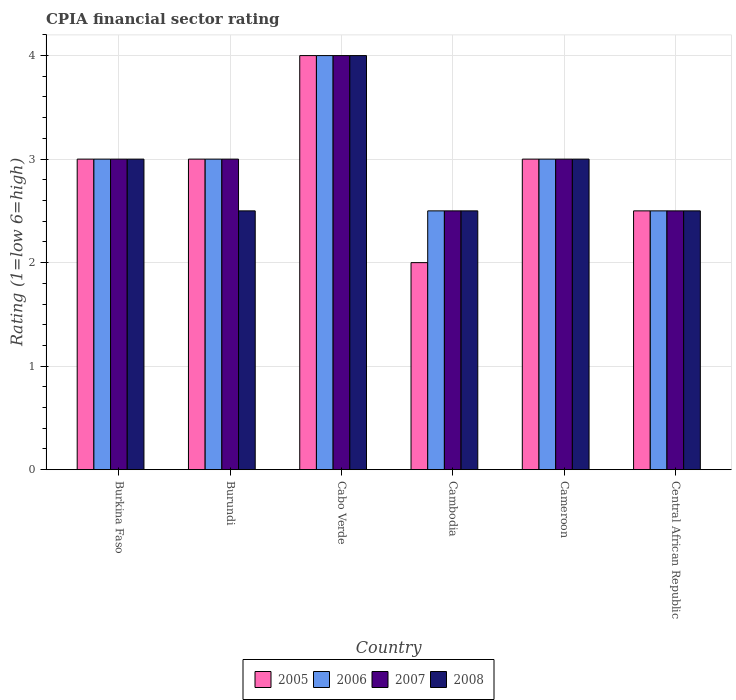How many groups of bars are there?
Your response must be concise. 6. Are the number of bars per tick equal to the number of legend labels?
Provide a short and direct response. Yes. Are the number of bars on each tick of the X-axis equal?
Offer a very short reply. Yes. How many bars are there on the 3rd tick from the left?
Provide a short and direct response. 4. How many bars are there on the 3rd tick from the right?
Keep it short and to the point. 4. What is the label of the 1st group of bars from the left?
Offer a very short reply. Burkina Faso. Across all countries, what is the maximum CPIA rating in 2006?
Provide a short and direct response. 4. Across all countries, what is the minimum CPIA rating in 2005?
Provide a short and direct response. 2. In which country was the CPIA rating in 2008 maximum?
Your response must be concise. Cabo Verde. In which country was the CPIA rating in 2007 minimum?
Offer a terse response. Cambodia. What is the average CPIA rating in 2005 per country?
Provide a succinct answer. 2.92. What is the difference between the CPIA rating of/in 2005 and CPIA rating of/in 2006 in Cameroon?
Provide a succinct answer. 0. Is the CPIA rating in 2006 in Burundi less than that in Cameroon?
Your answer should be compact. No. What is the difference between the highest and the second highest CPIA rating in 2006?
Offer a very short reply. -1. What is the difference between the highest and the lowest CPIA rating in 2006?
Offer a very short reply. 1.5. In how many countries, is the CPIA rating in 2007 greater than the average CPIA rating in 2007 taken over all countries?
Ensure brevity in your answer.  1. Is the sum of the CPIA rating in 2006 in Burkina Faso and Burundi greater than the maximum CPIA rating in 2008 across all countries?
Your response must be concise. Yes. Is it the case that in every country, the sum of the CPIA rating in 2008 and CPIA rating in 2006 is greater than the sum of CPIA rating in 2005 and CPIA rating in 2007?
Your answer should be compact. No. What does the 2nd bar from the right in Cambodia represents?
Your answer should be compact. 2007. How many bars are there?
Make the answer very short. 24. What is the difference between two consecutive major ticks on the Y-axis?
Offer a terse response. 1. Does the graph contain any zero values?
Keep it short and to the point. No. Where does the legend appear in the graph?
Your answer should be very brief. Bottom center. How are the legend labels stacked?
Make the answer very short. Horizontal. What is the title of the graph?
Your response must be concise. CPIA financial sector rating. What is the label or title of the X-axis?
Your answer should be compact. Country. What is the Rating (1=low 6=high) in 2006 in Burkina Faso?
Offer a terse response. 3. What is the Rating (1=low 6=high) in 2007 in Burkina Faso?
Your answer should be compact. 3. What is the Rating (1=low 6=high) of 2008 in Burkina Faso?
Provide a short and direct response. 3. What is the Rating (1=low 6=high) in 2005 in Burundi?
Your answer should be very brief. 3. What is the Rating (1=low 6=high) of 2006 in Burundi?
Provide a succinct answer. 3. What is the Rating (1=low 6=high) in 2008 in Burundi?
Your answer should be compact. 2.5. What is the Rating (1=low 6=high) in 2007 in Cabo Verde?
Provide a succinct answer. 4. What is the Rating (1=low 6=high) in 2005 in Cambodia?
Provide a short and direct response. 2. What is the Rating (1=low 6=high) in 2008 in Cambodia?
Provide a short and direct response. 2.5. What is the Rating (1=low 6=high) of 2007 in Cameroon?
Keep it short and to the point. 3. What is the Rating (1=low 6=high) in 2008 in Cameroon?
Give a very brief answer. 3. What is the Rating (1=low 6=high) of 2006 in Central African Republic?
Make the answer very short. 2.5. What is the Rating (1=low 6=high) in 2007 in Central African Republic?
Provide a short and direct response. 2.5. Across all countries, what is the maximum Rating (1=low 6=high) in 2005?
Provide a succinct answer. 4. Across all countries, what is the maximum Rating (1=low 6=high) in 2006?
Give a very brief answer. 4. Across all countries, what is the minimum Rating (1=low 6=high) in 2006?
Provide a short and direct response. 2.5. Across all countries, what is the minimum Rating (1=low 6=high) in 2007?
Give a very brief answer. 2.5. Across all countries, what is the minimum Rating (1=low 6=high) of 2008?
Ensure brevity in your answer.  2.5. What is the difference between the Rating (1=low 6=high) of 2005 in Burkina Faso and that in Burundi?
Your answer should be compact. 0. What is the difference between the Rating (1=low 6=high) in 2008 in Burkina Faso and that in Burundi?
Provide a short and direct response. 0.5. What is the difference between the Rating (1=low 6=high) in 2005 in Burkina Faso and that in Cabo Verde?
Give a very brief answer. -1. What is the difference between the Rating (1=low 6=high) in 2006 in Burkina Faso and that in Cabo Verde?
Provide a succinct answer. -1. What is the difference between the Rating (1=low 6=high) in 2005 in Burkina Faso and that in Cambodia?
Provide a short and direct response. 1. What is the difference between the Rating (1=low 6=high) of 2006 in Burkina Faso and that in Cambodia?
Offer a very short reply. 0.5. What is the difference between the Rating (1=low 6=high) in 2008 in Burkina Faso and that in Cambodia?
Offer a terse response. 0.5. What is the difference between the Rating (1=low 6=high) in 2005 in Burkina Faso and that in Cameroon?
Provide a succinct answer. 0. What is the difference between the Rating (1=low 6=high) of 2008 in Burkina Faso and that in Cameroon?
Provide a short and direct response. 0. What is the difference between the Rating (1=low 6=high) in 2007 in Burundi and that in Cabo Verde?
Offer a very short reply. -1. What is the difference between the Rating (1=low 6=high) in 2005 in Burundi and that in Cambodia?
Offer a very short reply. 1. What is the difference between the Rating (1=low 6=high) of 2007 in Burundi and that in Cambodia?
Ensure brevity in your answer.  0.5. What is the difference between the Rating (1=low 6=high) of 2008 in Burundi and that in Cambodia?
Provide a short and direct response. 0. What is the difference between the Rating (1=low 6=high) in 2005 in Burundi and that in Cameroon?
Provide a succinct answer. 0. What is the difference between the Rating (1=low 6=high) in 2006 in Burundi and that in Cameroon?
Your answer should be compact. 0. What is the difference between the Rating (1=low 6=high) in 2006 in Burundi and that in Central African Republic?
Ensure brevity in your answer.  0.5. What is the difference between the Rating (1=low 6=high) in 2008 in Burundi and that in Central African Republic?
Give a very brief answer. 0. What is the difference between the Rating (1=low 6=high) in 2005 in Cabo Verde and that in Cambodia?
Offer a terse response. 2. What is the difference between the Rating (1=low 6=high) in 2008 in Cabo Verde and that in Cambodia?
Your answer should be compact. 1.5. What is the difference between the Rating (1=low 6=high) in 2005 in Cabo Verde and that in Cameroon?
Keep it short and to the point. 1. What is the difference between the Rating (1=low 6=high) in 2007 in Cabo Verde and that in Cameroon?
Offer a very short reply. 1. What is the difference between the Rating (1=low 6=high) of 2008 in Cabo Verde and that in Cameroon?
Offer a terse response. 1. What is the difference between the Rating (1=low 6=high) of 2005 in Cabo Verde and that in Central African Republic?
Give a very brief answer. 1.5. What is the difference between the Rating (1=low 6=high) in 2006 in Cabo Verde and that in Central African Republic?
Your response must be concise. 1.5. What is the difference between the Rating (1=low 6=high) in 2007 in Cambodia and that in Cameroon?
Provide a succinct answer. -0.5. What is the difference between the Rating (1=low 6=high) in 2005 in Cambodia and that in Central African Republic?
Give a very brief answer. -0.5. What is the difference between the Rating (1=low 6=high) of 2005 in Cameroon and that in Central African Republic?
Give a very brief answer. 0.5. What is the difference between the Rating (1=low 6=high) in 2005 in Burkina Faso and the Rating (1=low 6=high) in 2006 in Burundi?
Offer a very short reply. 0. What is the difference between the Rating (1=low 6=high) in 2005 in Burkina Faso and the Rating (1=low 6=high) in 2007 in Burundi?
Give a very brief answer. 0. What is the difference between the Rating (1=low 6=high) in 2005 in Burkina Faso and the Rating (1=low 6=high) in 2008 in Burundi?
Provide a succinct answer. 0.5. What is the difference between the Rating (1=low 6=high) in 2006 in Burkina Faso and the Rating (1=low 6=high) in 2007 in Burundi?
Offer a very short reply. 0. What is the difference between the Rating (1=low 6=high) of 2005 in Burkina Faso and the Rating (1=low 6=high) of 2006 in Cabo Verde?
Provide a short and direct response. -1. What is the difference between the Rating (1=low 6=high) in 2005 in Burkina Faso and the Rating (1=low 6=high) in 2007 in Cabo Verde?
Make the answer very short. -1. What is the difference between the Rating (1=low 6=high) of 2005 in Burkina Faso and the Rating (1=low 6=high) of 2008 in Cabo Verde?
Your response must be concise. -1. What is the difference between the Rating (1=low 6=high) in 2006 in Burkina Faso and the Rating (1=low 6=high) in 2007 in Cabo Verde?
Offer a very short reply. -1. What is the difference between the Rating (1=low 6=high) of 2005 in Burkina Faso and the Rating (1=low 6=high) of 2007 in Cambodia?
Give a very brief answer. 0.5. What is the difference between the Rating (1=low 6=high) in 2005 in Burkina Faso and the Rating (1=low 6=high) in 2008 in Cambodia?
Provide a succinct answer. 0.5. What is the difference between the Rating (1=low 6=high) in 2006 in Burkina Faso and the Rating (1=low 6=high) in 2007 in Cambodia?
Offer a very short reply. 0.5. What is the difference between the Rating (1=low 6=high) of 2006 in Burkina Faso and the Rating (1=low 6=high) of 2008 in Cambodia?
Your answer should be compact. 0.5. What is the difference between the Rating (1=low 6=high) in 2007 in Burkina Faso and the Rating (1=low 6=high) in 2008 in Cambodia?
Provide a succinct answer. 0.5. What is the difference between the Rating (1=low 6=high) of 2005 in Burkina Faso and the Rating (1=low 6=high) of 2006 in Cameroon?
Your response must be concise. 0. What is the difference between the Rating (1=low 6=high) of 2005 in Burkina Faso and the Rating (1=low 6=high) of 2007 in Cameroon?
Your answer should be very brief. 0. What is the difference between the Rating (1=low 6=high) of 2005 in Burkina Faso and the Rating (1=low 6=high) of 2008 in Cameroon?
Your response must be concise. 0. What is the difference between the Rating (1=low 6=high) in 2005 in Burkina Faso and the Rating (1=low 6=high) in 2006 in Central African Republic?
Make the answer very short. 0.5. What is the difference between the Rating (1=low 6=high) in 2005 in Burkina Faso and the Rating (1=low 6=high) in 2007 in Central African Republic?
Your response must be concise. 0.5. What is the difference between the Rating (1=low 6=high) in 2006 in Burkina Faso and the Rating (1=low 6=high) in 2008 in Central African Republic?
Provide a succinct answer. 0.5. What is the difference between the Rating (1=low 6=high) of 2007 in Burkina Faso and the Rating (1=low 6=high) of 2008 in Central African Republic?
Provide a succinct answer. 0.5. What is the difference between the Rating (1=low 6=high) in 2005 in Burundi and the Rating (1=low 6=high) in 2007 in Cabo Verde?
Your answer should be compact. -1. What is the difference between the Rating (1=low 6=high) of 2005 in Burundi and the Rating (1=low 6=high) of 2008 in Cabo Verde?
Provide a short and direct response. -1. What is the difference between the Rating (1=low 6=high) of 2007 in Burundi and the Rating (1=low 6=high) of 2008 in Cabo Verde?
Keep it short and to the point. -1. What is the difference between the Rating (1=low 6=high) of 2006 in Burundi and the Rating (1=low 6=high) of 2008 in Cambodia?
Your answer should be very brief. 0.5. What is the difference between the Rating (1=low 6=high) of 2007 in Burundi and the Rating (1=low 6=high) of 2008 in Cambodia?
Give a very brief answer. 0.5. What is the difference between the Rating (1=low 6=high) of 2005 in Burundi and the Rating (1=low 6=high) of 2006 in Cameroon?
Make the answer very short. 0. What is the difference between the Rating (1=low 6=high) of 2005 in Burundi and the Rating (1=low 6=high) of 2007 in Cameroon?
Your answer should be compact. 0. What is the difference between the Rating (1=low 6=high) in 2005 in Burundi and the Rating (1=low 6=high) in 2008 in Cameroon?
Give a very brief answer. 0. What is the difference between the Rating (1=low 6=high) of 2006 in Burundi and the Rating (1=low 6=high) of 2007 in Cameroon?
Offer a terse response. 0. What is the difference between the Rating (1=low 6=high) of 2007 in Burundi and the Rating (1=low 6=high) of 2008 in Cameroon?
Make the answer very short. 0. What is the difference between the Rating (1=low 6=high) of 2007 in Burundi and the Rating (1=low 6=high) of 2008 in Central African Republic?
Keep it short and to the point. 0.5. What is the difference between the Rating (1=low 6=high) in 2005 in Cabo Verde and the Rating (1=low 6=high) in 2006 in Cambodia?
Give a very brief answer. 1.5. What is the difference between the Rating (1=low 6=high) in 2005 in Cabo Verde and the Rating (1=low 6=high) in 2007 in Cambodia?
Your answer should be compact. 1.5. What is the difference between the Rating (1=low 6=high) in 2006 in Cabo Verde and the Rating (1=low 6=high) in 2007 in Cambodia?
Your answer should be compact. 1.5. What is the difference between the Rating (1=low 6=high) in 2007 in Cabo Verde and the Rating (1=low 6=high) in 2008 in Cambodia?
Offer a very short reply. 1.5. What is the difference between the Rating (1=low 6=high) of 2005 in Cabo Verde and the Rating (1=low 6=high) of 2007 in Cameroon?
Give a very brief answer. 1. What is the difference between the Rating (1=low 6=high) of 2006 in Cabo Verde and the Rating (1=low 6=high) of 2008 in Cameroon?
Keep it short and to the point. 1. What is the difference between the Rating (1=low 6=high) of 2005 in Cabo Verde and the Rating (1=low 6=high) of 2007 in Central African Republic?
Offer a very short reply. 1.5. What is the difference between the Rating (1=low 6=high) of 2006 in Cambodia and the Rating (1=low 6=high) of 2008 in Cameroon?
Your answer should be compact. -0.5. What is the difference between the Rating (1=low 6=high) in 2007 in Cambodia and the Rating (1=low 6=high) in 2008 in Cameroon?
Ensure brevity in your answer.  -0.5. What is the difference between the Rating (1=low 6=high) of 2005 in Cambodia and the Rating (1=low 6=high) of 2006 in Central African Republic?
Make the answer very short. -0.5. What is the difference between the Rating (1=low 6=high) of 2006 in Cambodia and the Rating (1=low 6=high) of 2008 in Central African Republic?
Your answer should be compact. 0. What is the difference between the Rating (1=low 6=high) of 2007 in Cambodia and the Rating (1=low 6=high) of 2008 in Central African Republic?
Your answer should be very brief. 0. What is the difference between the Rating (1=low 6=high) in 2005 in Cameroon and the Rating (1=low 6=high) in 2007 in Central African Republic?
Provide a short and direct response. 0.5. What is the difference between the Rating (1=low 6=high) of 2005 in Cameroon and the Rating (1=low 6=high) of 2008 in Central African Republic?
Ensure brevity in your answer.  0.5. What is the difference between the Rating (1=low 6=high) of 2006 in Cameroon and the Rating (1=low 6=high) of 2008 in Central African Republic?
Make the answer very short. 0.5. What is the difference between the Rating (1=low 6=high) in 2007 in Cameroon and the Rating (1=low 6=high) in 2008 in Central African Republic?
Ensure brevity in your answer.  0.5. What is the average Rating (1=low 6=high) of 2005 per country?
Your answer should be very brief. 2.92. What is the average Rating (1=low 6=high) in 2006 per country?
Provide a succinct answer. 3. What is the average Rating (1=low 6=high) in 2007 per country?
Ensure brevity in your answer.  3. What is the average Rating (1=low 6=high) in 2008 per country?
Make the answer very short. 2.92. What is the difference between the Rating (1=low 6=high) of 2005 and Rating (1=low 6=high) of 2007 in Burkina Faso?
Make the answer very short. 0. What is the difference between the Rating (1=low 6=high) in 2006 and Rating (1=low 6=high) in 2007 in Burkina Faso?
Your answer should be compact. 0. What is the difference between the Rating (1=low 6=high) in 2005 and Rating (1=low 6=high) in 2007 in Burundi?
Offer a very short reply. 0. What is the difference between the Rating (1=low 6=high) in 2007 and Rating (1=low 6=high) in 2008 in Burundi?
Your answer should be compact. 0.5. What is the difference between the Rating (1=low 6=high) of 2006 and Rating (1=low 6=high) of 2008 in Cabo Verde?
Your answer should be compact. 0. What is the difference between the Rating (1=low 6=high) of 2005 and Rating (1=low 6=high) of 2006 in Cambodia?
Make the answer very short. -0.5. What is the difference between the Rating (1=low 6=high) of 2005 and Rating (1=low 6=high) of 2007 in Cambodia?
Offer a very short reply. -0.5. What is the difference between the Rating (1=low 6=high) in 2005 and Rating (1=low 6=high) in 2008 in Cambodia?
Your response must be concise. -0.5. What is the difference between the Rating (1=low 6=high) of 2005 and Rating (1=low 6=high) of 2008 in Cameroon?
Provide a short and direct response. 0. What is the difference between the Rating (1=low 6=high) of 2006 and Rating (1=low 6=high) of 2008 in Cameroon?
Make the answer very short. 0. What is the difference between the Rating (1=low 6=high) in 2005 and Rating (1=low 6=high) in 2006 in Central African Republic?
Offer a terse response. 0. What is the difference between the Rating (1=low 6=high) in 2005 and Rating (1=low 6=high) in 2008 in Central African Republic?
Ensure brevity in your answer.  0. What is the difference between the Rating (1=low 6=high) in 2006 and Rating (1=low 6=high) in 2007 in Central African Republic?
Your response must be concise. 0. What is the difference between the Rating (1=low 6=high) of 2006 and Rating (1=low 6=high) of 2008 in Central African Republic?
Your answer should be compact. 0. What is the difference between the Rating (1=low 6=high) in 2007 and Rating (1=low 6=high) in 2008 in Central African Republic?
Make the answer very short. 0. What is the ratio of the Rating (1=low 6=high) of 2005 in Burkina Faso to that in Burundi?
Provide a succinct answer. 1. What is the ratio of the Rating (1=low 6=high) in 2006 in Burkina Faso to that in Burundi?
Provide a short and direct response. 1. What is the ratio of the Rating (1=low 6=high) of 2006 in Burkina Faso to that in Cabo Verde?
Offer a terse response. 0.75. What is the ratio of the Rating (1=low 6=high) of 2007 in Burkina Faso to that in Cabo Verde?
Your answer should be very brief. 0.75. What is the ratio of the Rating (1=low 6=high) in 2008 in Burkina Faso to that in Cabo Verde?
Your response must be concise. 0.75. What is the ratio of the Rating (1=low 6=high) in 2005 in Burkina Faso to that in Cambodia?
Your answer should be compact. 1.5. What is the ratio of the Rating (1=low 6=high) of 2006 in Burkina Faso to that in Cambodia?
Your answer should be very brief. 1.2. What is the ratio of the Rating (1=low 6=high) of 2007 in Burkina Faso to that in Cambodia?
Offer a very short reply. 1.2. What is the ratio of the Rating (1=low 6=high) in 2007 in Burkina Faso to that in Central African Republic?
Make the answer very short. 1.2. What is the ratio of the Rating (1=low 6=high) of 2005 in Burundi to that in Cabo Verde?
Offer a very short reply. 0.75. What is the ratio of the Rating (1=low 6=high) in 2006 in Burundi to that in Cabo Verde?
Provide a short and direct response. 0.75. What is the ratio of the Rating (1=low 6=high) in 2008 in Burundi to that in Cabo Verde?
Keep it short and to the point. 0.62. What is the ratio of the Rating (1=low 6=high) in 2007 in Burundi to that in Cambodia?
Your answer should be compact. 1.2. What is the ratio of the Rating (1=low 6=high) of 2008 in Burundi to that in Cambodia?
Your answer should be very brief. 1. What is the ratio of the Rating (1=low 6=high) of 2008 in Burundi to that in Cameroon?
Give a very brief answer. 0.83. What is the ratio of the Rating (1=low 6=high) in 2006 in Burundi to that in Central African Republic?
Offer a terse response. 1.2. What is the ratio of the Rating (1=low 6=high) of 2007 in Burundi to that in Central African Republic?
Your answer should be very brief. 1.2. What is the ratio of the Rating (1=low 6=high) in 2005 in Cabo Verde to that in Cambodia?
Give a very brief answer. 2. What is the ratio of the Rating (1=low 6=high) of 2005 in Cabo Verde to that in Cameroon?
Keep it short and to the point. 1.33. What is the ratio of the Rating (1=low 6=high) of 2007 in Cabo Verde to that in Cameroon?
Your answer should be compact. 1.33. What is the ratio of the Rating (1=low 6=high) in 2008 in Cabo Verde to that in Central African Republic?
Keep it short and to the point. 1.6. What is the ratio of the Rating (1=low 6=high) of 2005 in Cambodia to that in Cameroon?
Give a very brief answer. 0.67. What is the ratio of the Rating (1=low 6=high) of 2006 in Cambodia to that in Cameroon?
Make the answer very short. 0.83. What is the ratio of the Rating (1=low 6=high) of 2007 in Cambodia to that in Cameroon?
Offer a very short reply. 0.83. What is the ratio of the Rating (1=low 6=high) of 2005 in Cambodia to that in Central African Republic?
Make the answer very short. 0.8. What is the ratio of the Rating (1=low 6=high) in 2006 in Cambodia to that in Central African Republic?
Your response must be concise. 1. What is the ratio of the Rating (1=low 6=high) of 2007 in Cambodia to that in Central African Republic?
Ensure brevity in your answer.  1. What is the ratio of the Rating (1=low 6=high) of 2008 in Cambodia to that in Central African Republic?
Make the answer very short. 1. What is the ratio of the Rating (1=low 6=high) of 2006 in Cameroon to that in Central African Republic?
Your answer should be compact. 1.2. What is the ratio of the Rating (1=low 6=high) in 2007 in Cameroon to that in Central African Republic?
Offer a terse response. 1.2. What is the ratio of the Rating (1=low 6=high) in 2008 in Cameroon to that in Central African Republic?
Your answer should be very brief. 1.2. What is the difference between the highest and the second highest Rating (1=low 6=high) of 2007?
Offer a terse response. 1. What is the difference between the highest and the second highest Rating (1=low 6=high) of 2008?
Your answer should be compact. 1. What is the difference between the highest and the lowest Rating (1=low 6=high) of 2006?
Your response must be concise. 1.5. What is the difference between the highest and the lowest Rating (1=low 6=high) in 2008?
Keep it short and to the point. 1.5. 